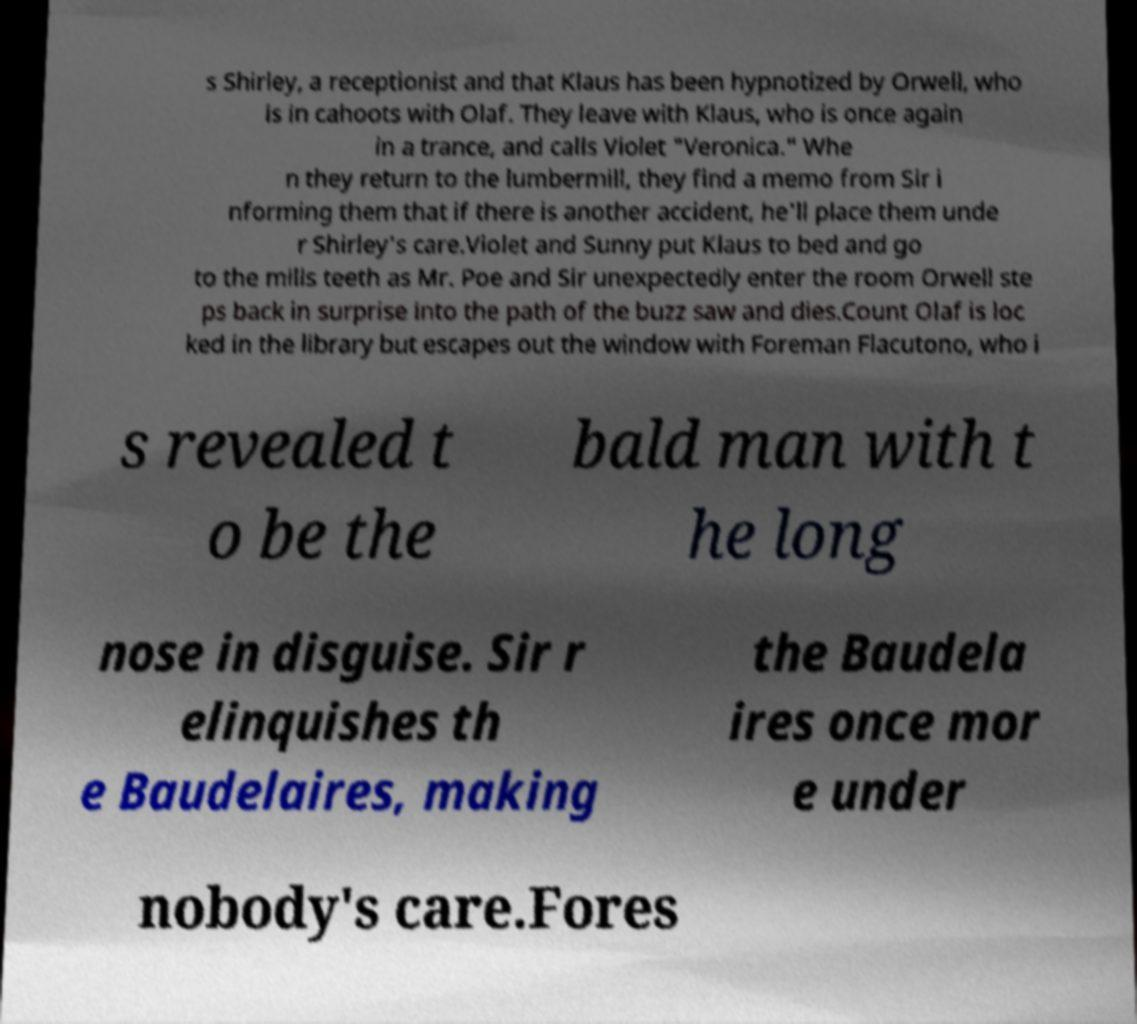I need the written content from this picture converted into text. Can you do that? s Shirley, a receptionist and that Klaus has been hypnotized by Orwell, who is in cahoots with Olaf. They leave with Klaus, who is once again in a trance, and calls Violet "Veronica." Whe n they return to the lumbermill, they find a memo from Sir i nforming them that if there is another accident, he'll place them unde r Shirley's care.Violet and Sunny put Klaus to bed and go to the mills teeth as Mr. Poe and Sir unexpectedly enter the room Orwell ste ps back in surprise into the path of the buzz saw and dies.Count Olaf is loc ked in the library but escapes out the window with Foreman Flacutono, who i s revealed t o be the bald man with t he long nose in disguise. Sir r elinquishes th e Baudelaires, making the Baudela ires once mor e under nobody's care.Fores 